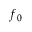Convert formula to latex. <formula><loc_0><loc_0><loc_500><loc_500>f _ { 0 }</formula> 